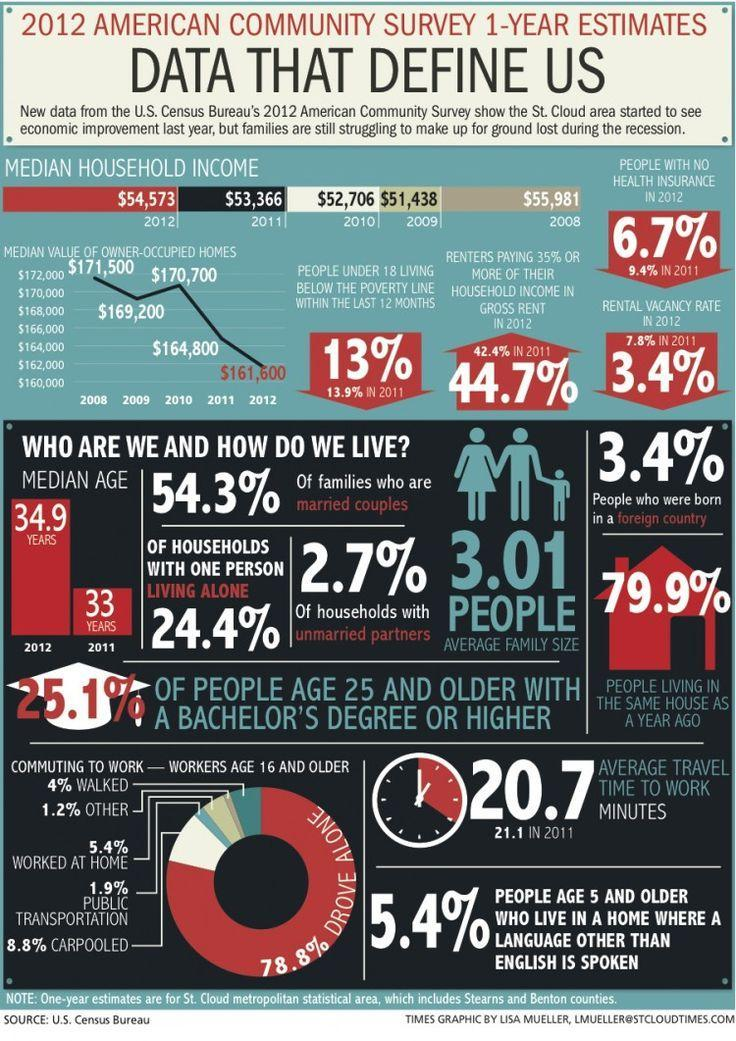What is the increase in median household income from 2009 to 2011?
Answer the question with a short phrase. $1,928 What is the increase in percentage of renters paying 35% or more of their household income in gross rent from 2011 to 2012? 2.3% Which year has the second lowest median household income according to the infographic? 2010 What is the decrease in percentage of people with no health insurance from 2011 to 2012? 2.7% What is the increase in median household income from 2009 to 2010? $1,268 What is the second most used mode of commuting to work for workers age 16 and olders? carpooled What is the decrease in percentage of people under 18 living below the poverty line within the last 12 months from 2011 to 2012? .9% What is the fourth most used mode of commuting to work for workers age 16 and olders? walking What is the decrease in percentage of rental vacancy rate from 2011 to 2012? 4.4% Which year has the second highest median value of owner-occupied homes? 2010 Which year has the second lowest median value of owner-occupied homes? 2011 Which year has the second highest median household income according to the infographic? 2012 